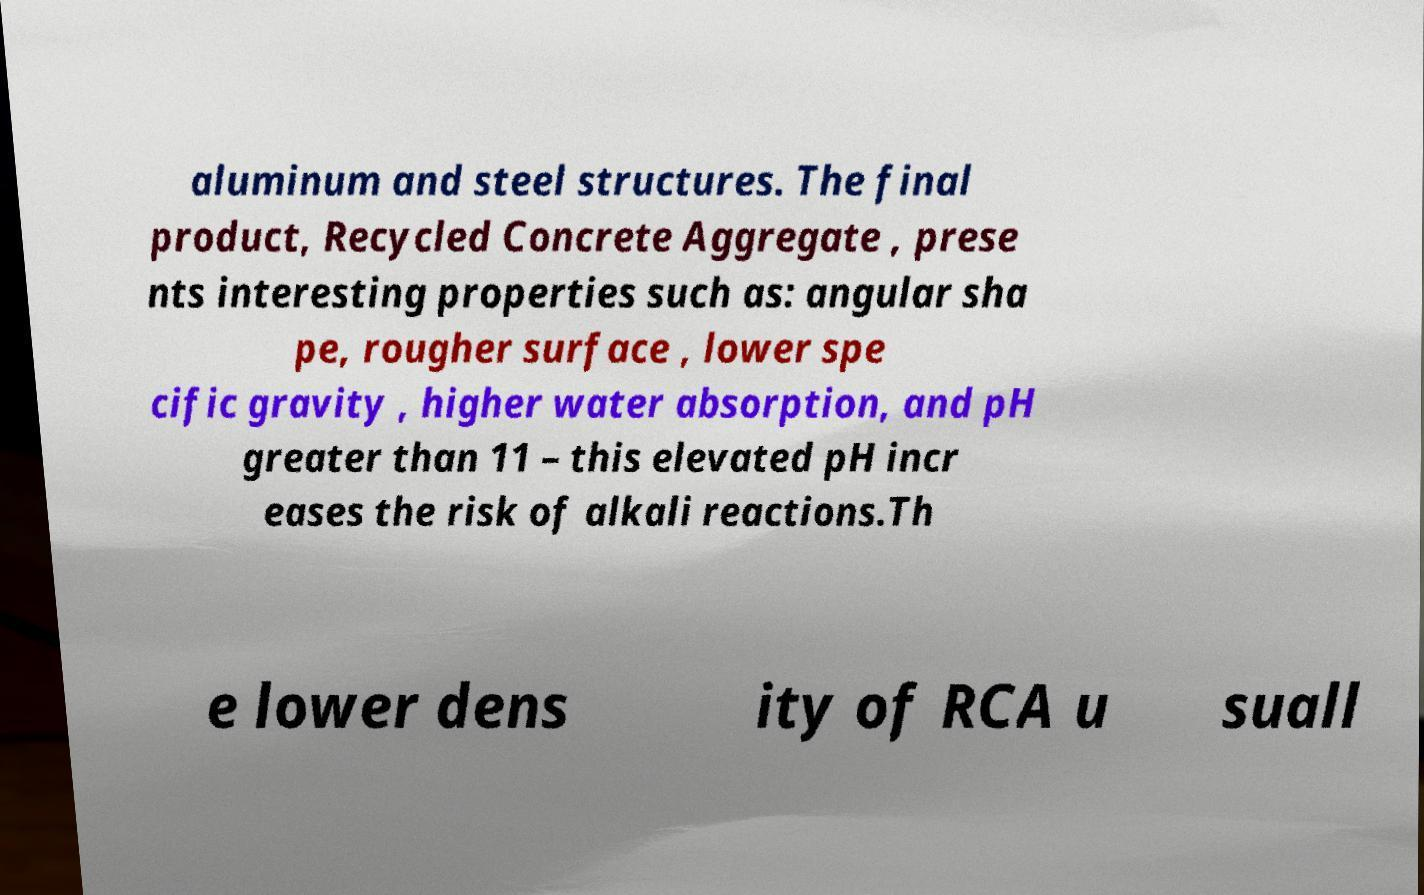Please read and relay the text visible in this image. What does it say? aluminum and steel structures. The final product, Recycled Concrete Aggregate , prese nts interesting properties such as: angular sha pe, rougher surface , lower spe cific gravity , higher water absorption, and pH greater than 11 – this elevated pH incr eases the risk of alkali reactions.Th e lower dens ity of RCA u suall 